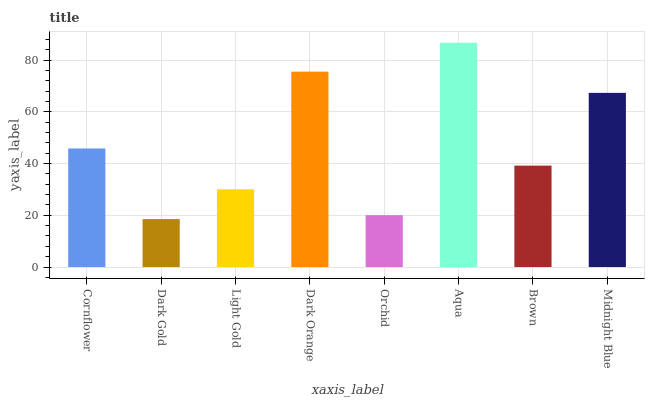Is Dark Gold the minimum?
Answer yes or no. Yes. Is Aqua the maximum?
Answer yes or no. Yes. Is Light Gold the minimum?
Answer yes or no. No. Is Light Gold the maximum?
Answer yes or no. No. Is Light Gold greater than Dark Gold?
Answer yes or no. Yes. Is Dark Gold less than Light Gold?
Answer yes or no. Yes. Is Dark Gold greater than Light Gold?
Answer yes or no. No. Is Light Gold less than Dark Gold?
Answer yes or no. No. Is Cornflower the high median?
Answer yes or no. Yes. Is Brown the low median?
Answer yes or no. Yes. Is Aqua the high median?
Answer yes or no. No. Is Cornflower the low median?
Answer yes or no. No. 